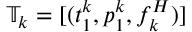Convert formula to latex. <formula><loc_0><loc_0><loc_500><loc_500>\mathbb { T } _ { k } = [ ( t _ { 1 } ^ { k } , p _ { 1 } ^ { k } , f _ { k } ^ { H } ) ]</formula> 